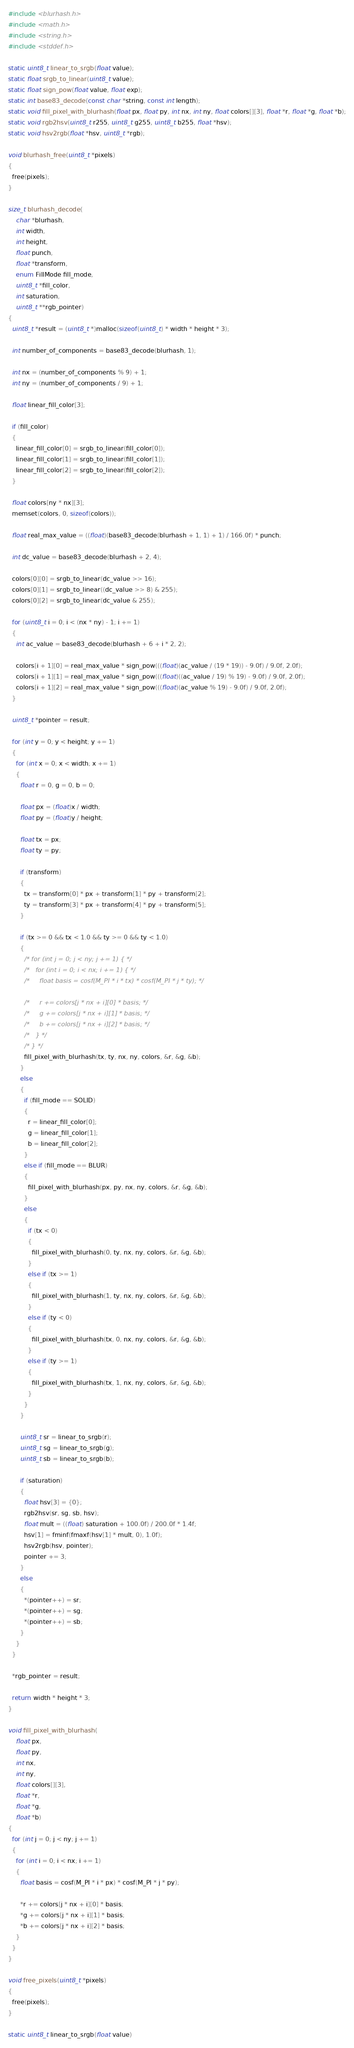<code> <loc_0><loc_0><loc_500><loc_500><_C_>#include <blurhash.h>
#include <math.h>
#include <string.h>
#include <stddef.h>

static uint8_t linear_to_srgb(float value);
static float srgb_to_linear(uint8_t value);
static float sign_pow(float value, float exp);
static int base83_decode(const char *string, const int length);
static void fill_pixel_with_blurhash(float px, float py, int nx, int ny, float colors[][3], float *r, float *g, float *b);
static void rgb2hsv(uint8_t r255, uint8_t g255, uint8_t b255, float *hsv);
static void hsv2rgb(float *hsv, uint8_t *rgb);

void blurhash_free(uint8_t *pixels)
{
  free(pixels);
}

size_t blurhash_decode(
    char *blurhash,
    int width,
    int height,
    float punch,
    float *transform,
    enum FillMode fill_mode,
    uint8_t *fill_color,
    int saturation,
    uint8_t **rgb_pointer)
{
  uint8_t *result = (uint8_t *)malloc(sizeof(uint8_t) * width * height * 3);

  int number_of_components = base83_decode(blurhash, 1);

  int nx = (number_of_components % 9) + 1;
  int ny = (number_of_components / 9) + 1;

  float linear_fill_color[3];

  if (fill_color)
  {
    linear_fill_color[0] = srgb_to_linear(fill_color[0]);
    linear_fill_color[1] = srgb_to_linear(fill_color[1]);
    linear_fill_color[2] = srgb_to_linear(fill_color[2]);
  }

  float colors[ny * nx][3];
  memset(colors, 0, sizeof(colors));

  float real_max_value = ((float)(base83_decode(blurhash + 1, 1) + 1) / 166.0f) * punch;

  int dc_value = base83_decode(blurhash + 2, 4);

  colors[0][0] = srgb_to_linear(dc_value >> 16);
  colors[0][1] = srgb_to_linear((dc_value >> 8) & 255);
  colors[0][2] = srgb_to_linear(dc_value & 255);

  for (uint8_t i = 0; i < (nx * ny) - 1; i += 1)
  {
    int ac_value = base83_decode(blurhash + 6 + i * 2, 2);

    colors[i + 1][0] = real_max_value * sign_pow(((float)(ac_value / (19 * 19)) - 9.0f) / 9.0f, 2.0f);
    colors[i + 1][1] = real_max_value * sign_pow(((float)((ac_value / 19) % 19) - 9.0f) / 9.0f, 2.0f);
    colors[i + 1][2] = real_max_value * sign_pow(((float)(ac_value % 19) - 9.0f) / 9.0f, 2.0f);
  }

  uint8_t *pointer = result;

  for (int y = 0; y < height; y += 1)
  {
    for (int x = 0; x < width; x += 1)
    {
      float r = 0, g = 0, b = 0;

      float px = (float)x / width;
      float py = (float)y / height;

      float tx = px;
      float ty = py;

      if (transform)
      {
        tx = transform[0] * px + transform[1] * py + transform[2];
        ty = transform[3] * px + transform[4] * py + transform[5];
      }

      if (tx >= 0 && tx < 1.0 && ty >= 0 && ty < 1.0)
      {
        /* for (int j = 0; j < ny; j += 1) { */
        /*   for (int i = 0; i < nx; i += 1) { */
        /*     float basis = cosf(M_PI * i * tx) * cosf(M_PI * j * ty); */

        /*     r += colors[j * nx + i][0] * basis; */
        /*     g += colors[j * nx + i][1] * basis; */
        /*     b += colors[j * nx + i][2] * basis; */
        /*   } */
        /* } */
        fill_pixel_with_blurhash(tx, ty, nx, ny, colors, &r, &g, &b);
      }
      else
      {
        if (fill_mode == SOLID)
        {
          r = linear_fill_color[0];
          g = linear_fill_color[1];
          b = linear_fill_color[2];
        }
        else if (fill_mode == BLUR)
        {
          fill_pixel_with_blurhash(px, py, nx, ny, colors, &r, &g, &b);
        }
        else
        {
          if (tx < 0)
          {
            fill_pixel_with_blurhash(0, ty, nx, ny, colors, &r, &g, &b);
          }
          else if (tx >= 1)
          {
            fill_pixel_with_blurhash(1, ty, nx, ny, colors, &r, &g, &b);
          }
          else if (ty < 0)
          {
            fill_pixel_with_blurhash(tx, 0, nx, ny, colors, &r, &g, &b);
          }
          else if (ty >= 1)
          {
            fill_pixel_with_blurhash(tx, 1, nx, ny, colors, &r, &g, &b);
          }
        }
      }

      uint8_t sr = linear_to_srgb(r);
      uint8_t sg = linear_to_srgb(g);
      uint8_t sb = linear_to_srgb(b);

      if (saturation)
      {
        float hsv[3] = {0};
        rgb2hsv(sr, sg, sb, hsv);
        float mult = ((float) saturation + 100.0f) / 200.0f * 1.4f;
        hsv[1] = fminf(fmaxf(hsv[1] * mult, 0), 1.0f);
        hsv2rgb(hsv, pointer);
        pointer += 3;
      }
      else
      {
        *(pointer++) = sr;
        *(pointer++) = sg;
        *(pointer++) = sb;
      }
    }
  }

  *rgb_pointer = result;

  return width * height * 3;
}

void fill_pixel_with_blurhash(
    float px,
    float py,
    int nx,
    int ny,
    float colors[][3],
    float *r,
    float *g,
    float *b)
{
  for (int j = 0; j < ny; j += 1)
  {
    for (int i = 0; i < nx; i += 1)
    {
      float basis = cosf(M_PI * i * px) * cosf(M_PI * j * py);

      *r += colors[j * nx + i][0] * basis;
      *g += colors[j * nx + i][1] * basis;
      *b += colors[j * nx + i][2] * basis;
    }
  }
}

void free_pixels(uint8_t *pixels)
{
  free(pixels);
}

static uint8_t linear_to_srgb(float value)</code> 